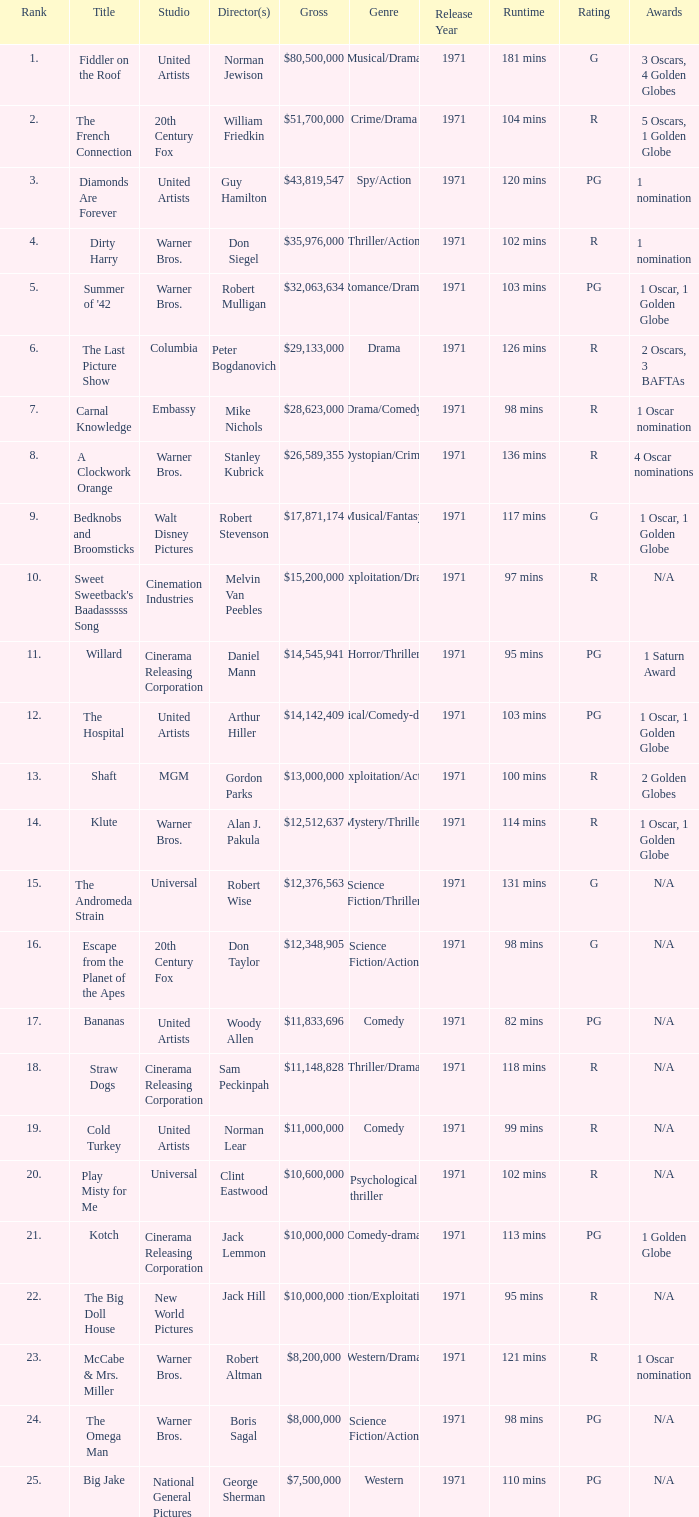What rank has a gross of $35,976,000? 4.0. 